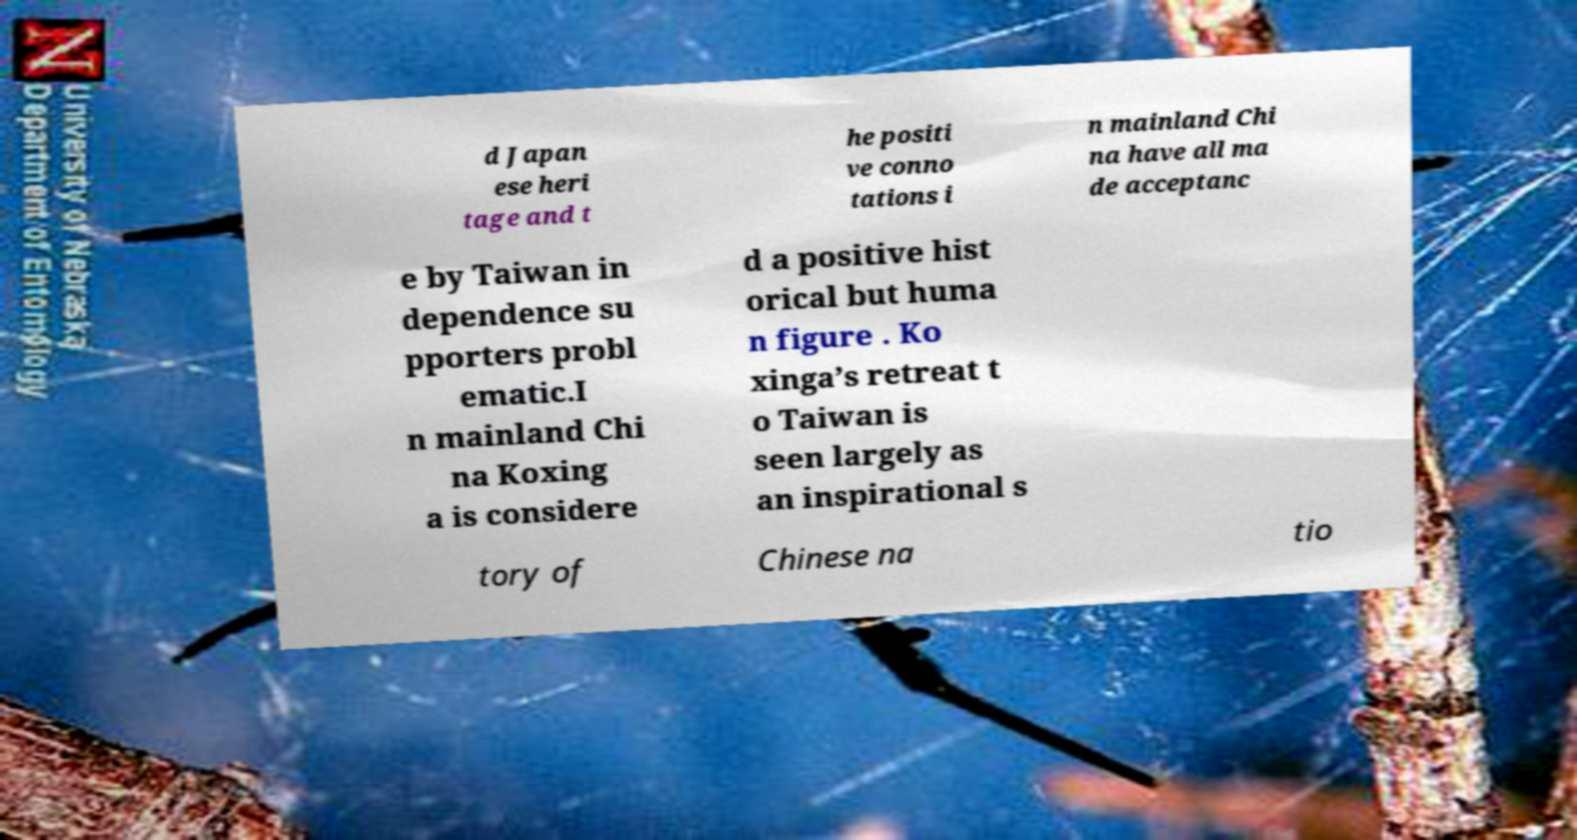For documentation purposes, I need the text within this image transcribed. Could you provide that? d Japan ese heri tage and t he positi ve conno tations i n mainland Chi na have all ma de acceptanc e by Taiwan in dependence su pporters probl ematic.I n mainland Chi na Koxing a is considere d a positive hist orical but huma n figure . Ko xinga’s retreat t o Taiwan is seen largely as an inspirational s tory of Chinese na tio 